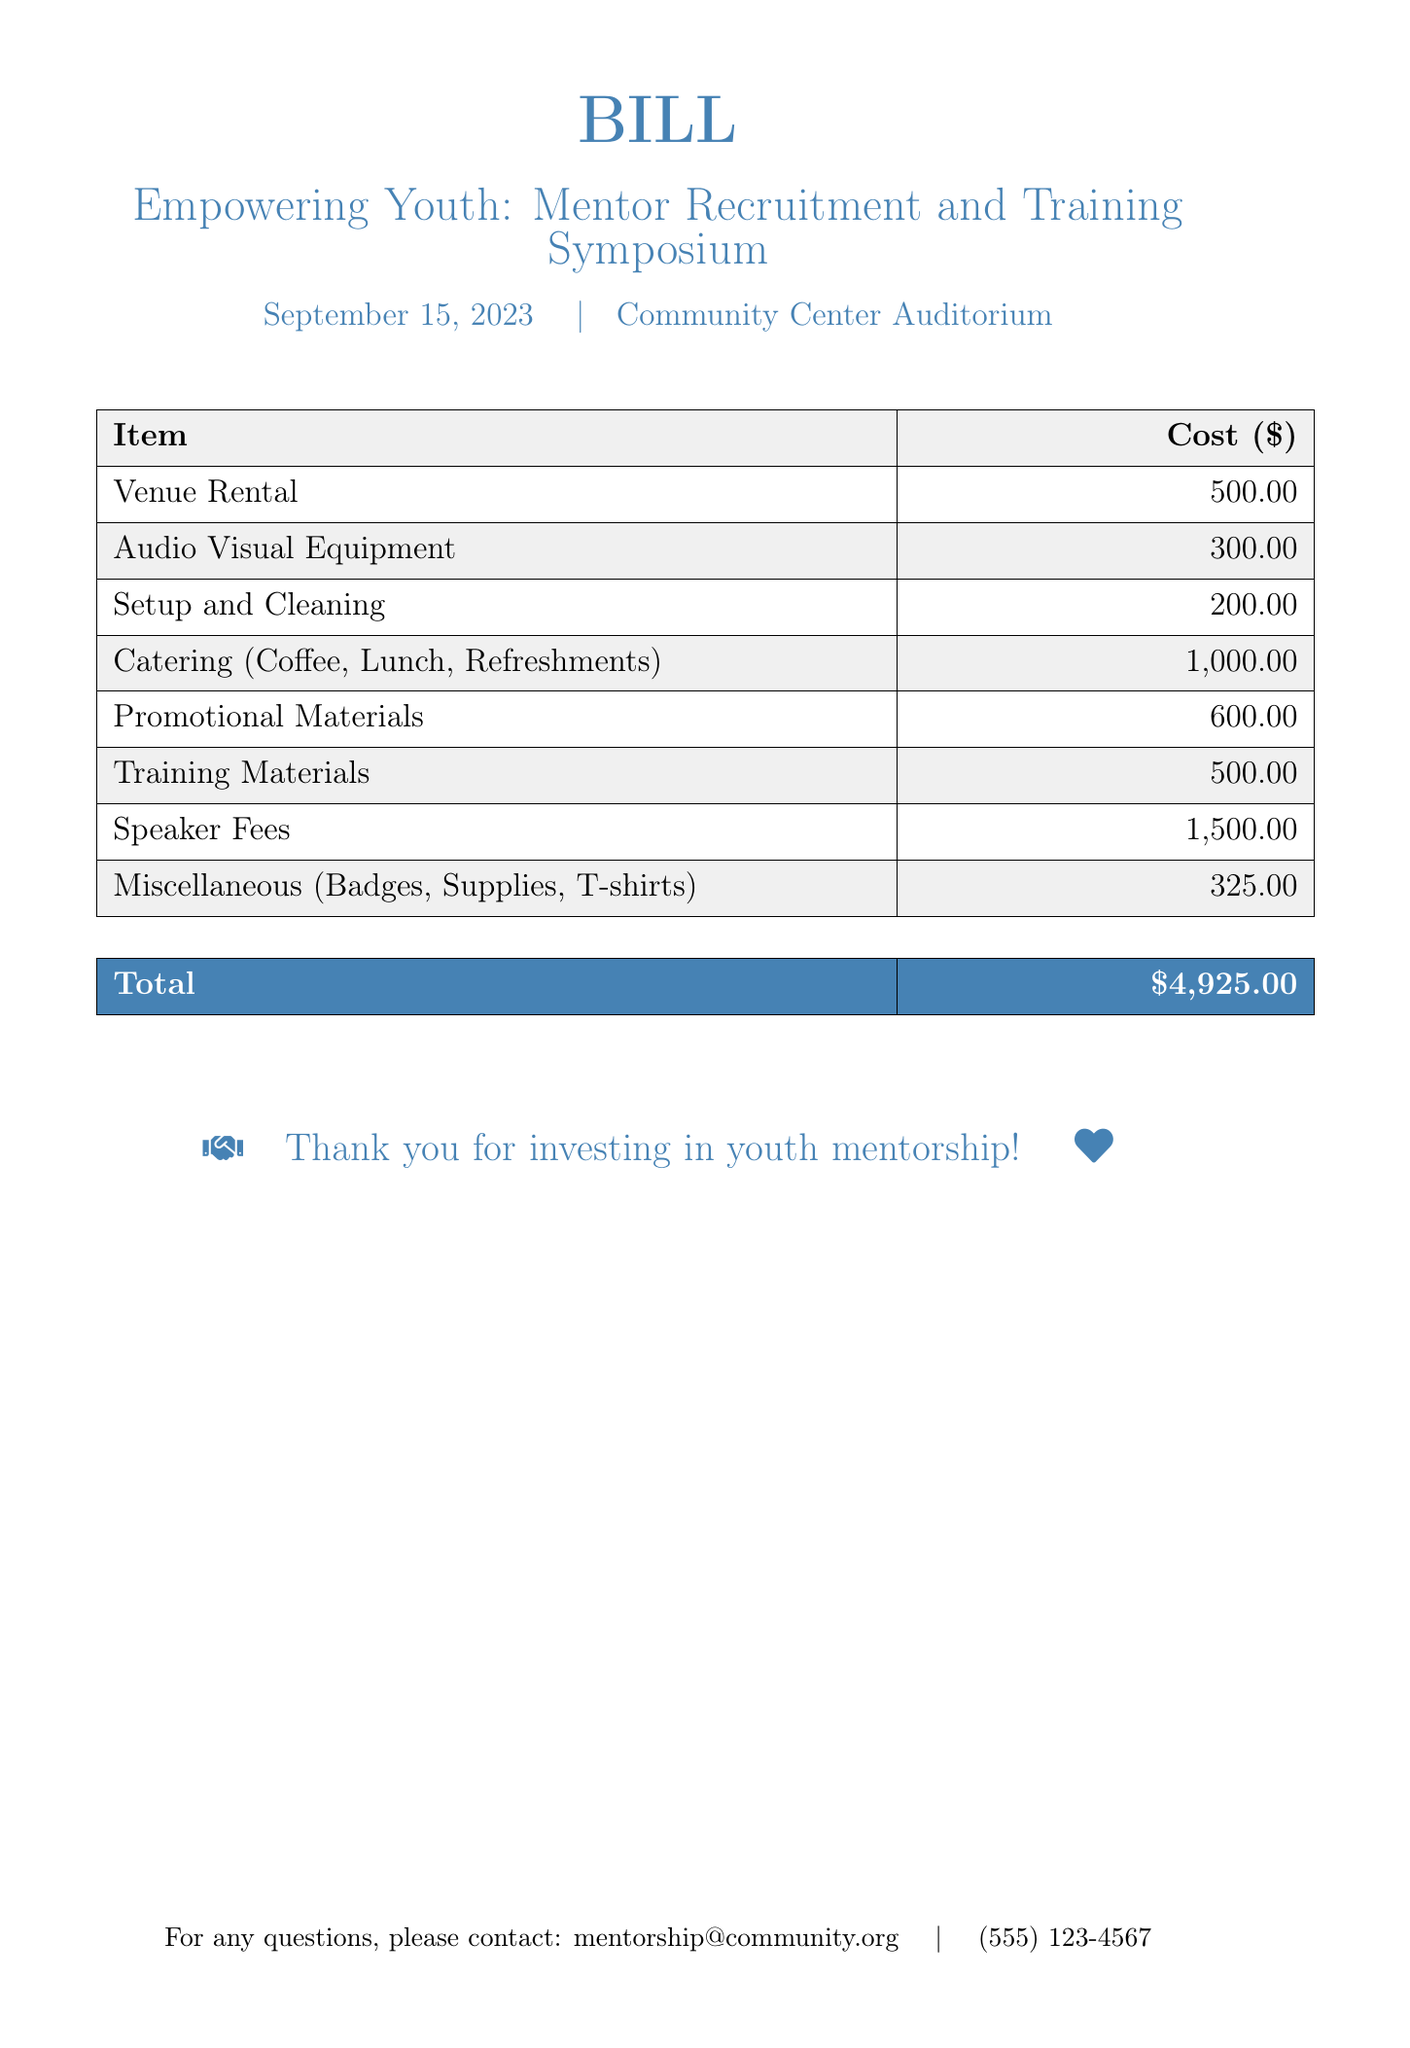what is the date of the event? The date of the event is mentioned in the document as September 15, 2023.
Answer: September 15, 2023 how much is allocated for catering? The document specifies the cost for catering as $1,000.00.
Answer: $1,000.00 what is the total cost for the event? The total cost is calculated by summing all individual costs listed in the document, which totals $4,925.00.
Answer: $4,925.00 how much was spent on speaker fees? The document shows the cost for speaker fees as $1,500.00.
Answer: $1,500.00 what is included in the miscellaneous expenses? Miscellaneous expenses cover badges, supplies, and T-shirts, as listed in the document.
Answer: Badges, Supplies, T-shirts what is the cost of the venue rental? The cost for the venue rental is explicitly stated as $500.00.
Answer: $500.00 what is the purpose of this bill? The bill outlines costs associated with the "Mentor Recruitment and Training Symposium."
Answer: Mentor Recruitment and Training Symposium how many categories of expenses are listed in the document? There are eight different expense categories provided in the document.
Answer: Eight who can be contacted for questions regarding the bill? The document lists an email and phone number for inquiries, specifically mentorship@community.org and (555) 123-4567.
Answer: mentorship@community.org 